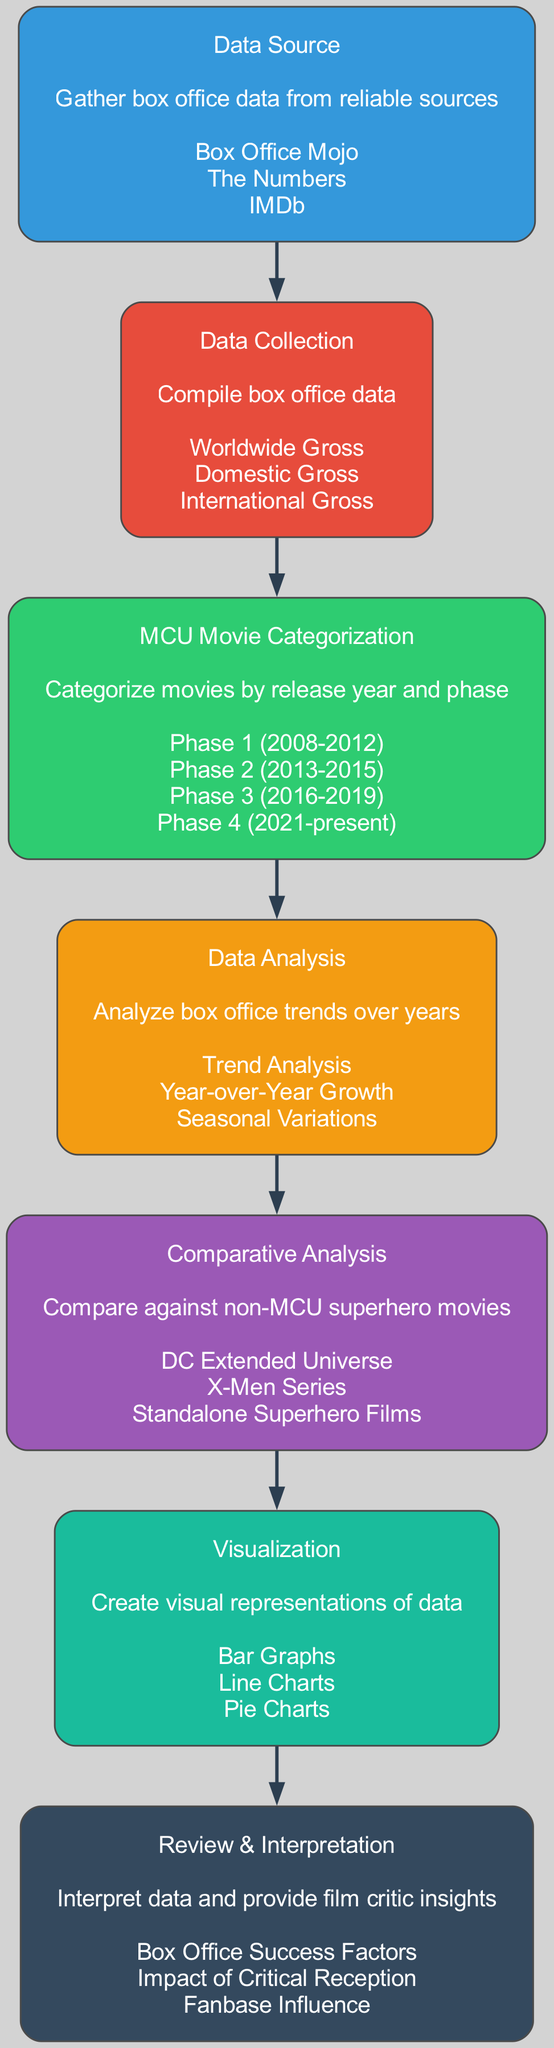What is the starting point of the diagram? The starting point of the diagram is the "Data Source" node, which is the first element in the flow indicating where the box office data is gathered.
Answer: Data Source How many elements are in the diagram? The diagram contains a total of seven elements representing different steps in the analysis process.
Answer: Seven Which stage follows "Data Collection"? The stage that follows "Data Collection" is "MCU Movie Categorization," indicating the progression from data compilation to organizing the information by movie release year and phase.
Answer: MCU Movie Categorization What type of visualization is included in the diagram? The visualization type mentioned in the diagram are "Bar Graphs," "Line Charts," and "Pie Charts," which are used to represent the analyzed data visually.
Answer: Bar Graphs, Line Charts, Pie Charts What are the three entities listed under "Comparative Analysis"? The three entities listed under "Comparative Analysis" are "DC Extended Universe," "X-Men Series," and "Standalone Superhero Films," indicating what MCU films will be compared against.
Answer: DC Extended Universe, X-Men Series, Standalone Superhero Films How does "Data Analysis" connect to "Review & Interpretation"? "Data Analysis" connects to "Review & Interpretation" as the output of analyzing box office trends serves as input for interpreting the data and providing insights in a critical context.
Answer: Data Analysis to Review & Interpretation What is the last phase of the analysis process? The last phase of the analysis process is "Review & Interpretation," which comprises summarizing and providing insights based on the collected and analyzed data.
Answer: Review & Interpretation 